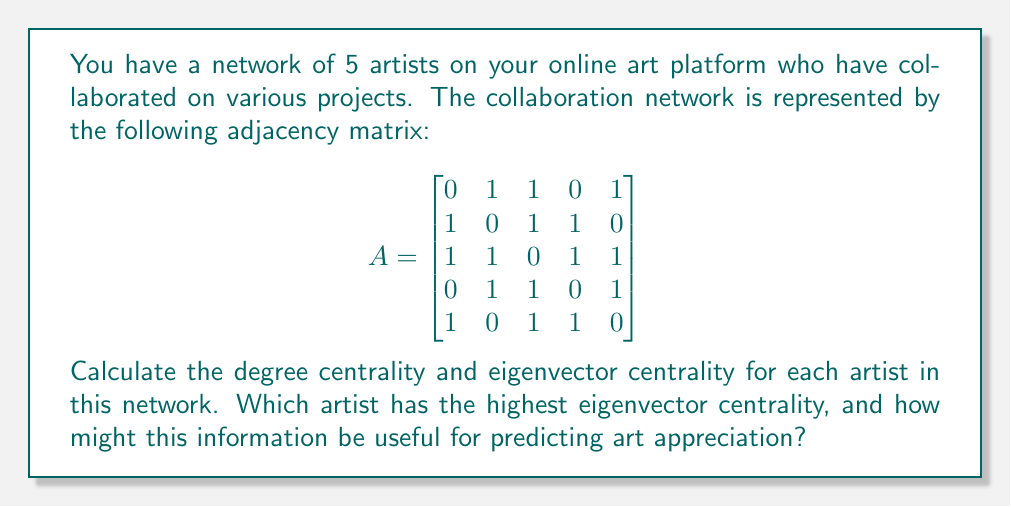Help me with this question. To solve this problem, we need to calculate two centrality measures: degree centrality and eigenvector centrality.

1. Degree Centrality:
Degree centrality is the number of direct connections an artist has. It can be calculated by summing the rows (or columns) of the adjacency matrix.

For each artist:
Artist 1: $3$
Artist 2: $3$
Artist 3: $4$
Artist 4: $3$
Artist 5: $3$

2. Eigenvector Centrality:
Eigenvector centrality takes into account not just the number of connections, but also the importance of those connections. It's calculated using the eigenvector corresponding to the largest eigenvalue of the adjacency matrix.

To find the eigenvector centrality:

a) Calculate the eigenvalues of A:
   $det(A - \lambda I) = 0$
   Solving this equation gives us the largest eigenvalue: $\lambda_{max} \approx 2.4812$

b) Find the eigenvector $\vec{v}$ corresponding to $\lambda_{max}$:
   $(A - \lambda_{max}I)\vec{v} = 0$

c) Solve this system of equations and normalize the resulting vector.

The normalized eigenvector is approximately:
$$\vec{v} \approx [0.4329, 0.4329, 0.5400, 0.4329, 0.4329]^T$$

This gives us the eigenvector centrality for each artist.

Artist 3 has the highest eigenvector centrality (0.5400), indicating that this artist not only has the most collaborations but also collaborates with other well-connected artists.

This information can be useful for predicting art appreciation because:
1. Artists with high eigenvector centrality are likely to have more influence in the art community.
2. Their collaborations might lead to more innovative and valuable artworks.
3. Their network position suggests they might have better access to resources and opportunities, potentially leading to higher-quality art.
4. Art created by well-connected artists may appreciate more in value due to increased exposure and recognition within the art community.
Answer: Degree Centrality:
Artist 1: 3
Artist 2: 3
Artist 3: 4
Artist 4: 3
Artist 5: 3

Eigenvector Centrality:
Artist 1: 0.4329
Artist 2: 0.4329
Artist 3: 0.5400
Artist 4: 0.4329
Artist 5: 0.4329

Artist 3 has the highest eigenvector centrality (0.5400). 